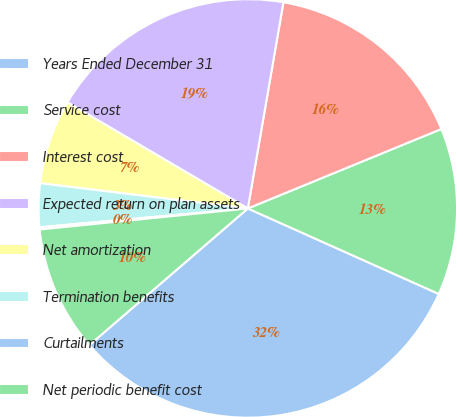Convert chart to OTSL. <chart><loc_0><loc_0><loc_500><loc_500><pie_chart><fcel>Years Ended December 31<fcel>Service cost<fcel>Interest cost<fcel>Expected return on plan assets<fcel>Net amortization<fcel>Termination benefits<fcel>Curtailments<fcel>Net periodic benefit cost<nl><fcel>31.98%<fcel>12.9%<fcel>16.08%<fcel>19.26%<fcel>6.54%<fcel>3.36%<fcel>0.17%<fcel>9.72%<nl></chart> 